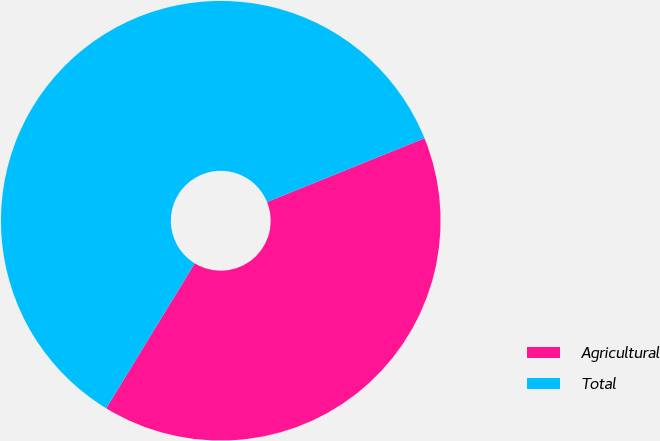Convert chart. <chart><loc_0><loc_0><loc_500><loc_500><pie_chart><fcel>Agricultural<fcel>Total<nl><fcel>39.85%<fcel>60.15%<nl></chart> 